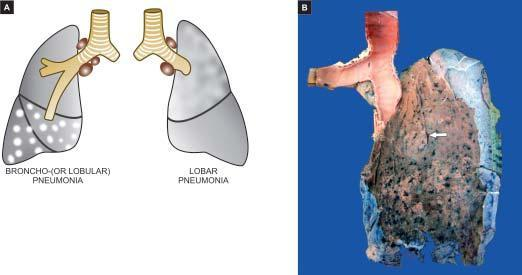s the intervening lung spongy?
Answer the question using a single word or phrase. Yes 